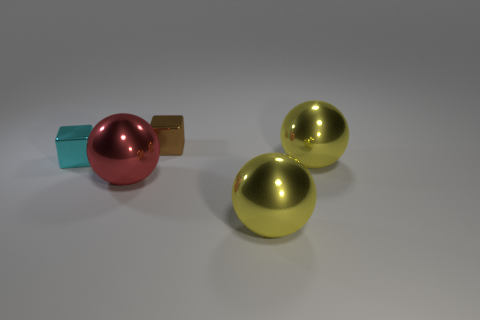What number of other things have the same shape as the small cyan shiny thing?
Your answer should be compact. 1. Does the cyan cube have the same material as the small thing that is behind the cyan block?
Provide a succinct answer. Yes. There is a block that is the same size as the brown shiny thing; what is its material?
Provide a succinct answer. Metal. Are there any brown metallic cubes that have the same size as the cyan cube?
Ensure brevity in your answer.  Yes. What shape is the brown metal object that is the same size as the cyan block?
Provide a short and direct response. Cube. There is a thing that is both behind the large red object and in front of the small cyan thing; what shape is it?
Your answer should be very brief. Sphere. There is a big red metal object in front of the object that is behind the tiny cyan metallic thing; is there a big shiny object that is in front of it?
Provide a short and direct response. Yes. What number of other objects are there of the same material as the red sphere?
Keep it short and to the point. 4. What number of metal objects are there?
Provide a short and direct response. 5. What number of things are big yellow metallic balls or things behind the cyan metallic block?
Offer a very short reply. 3. 